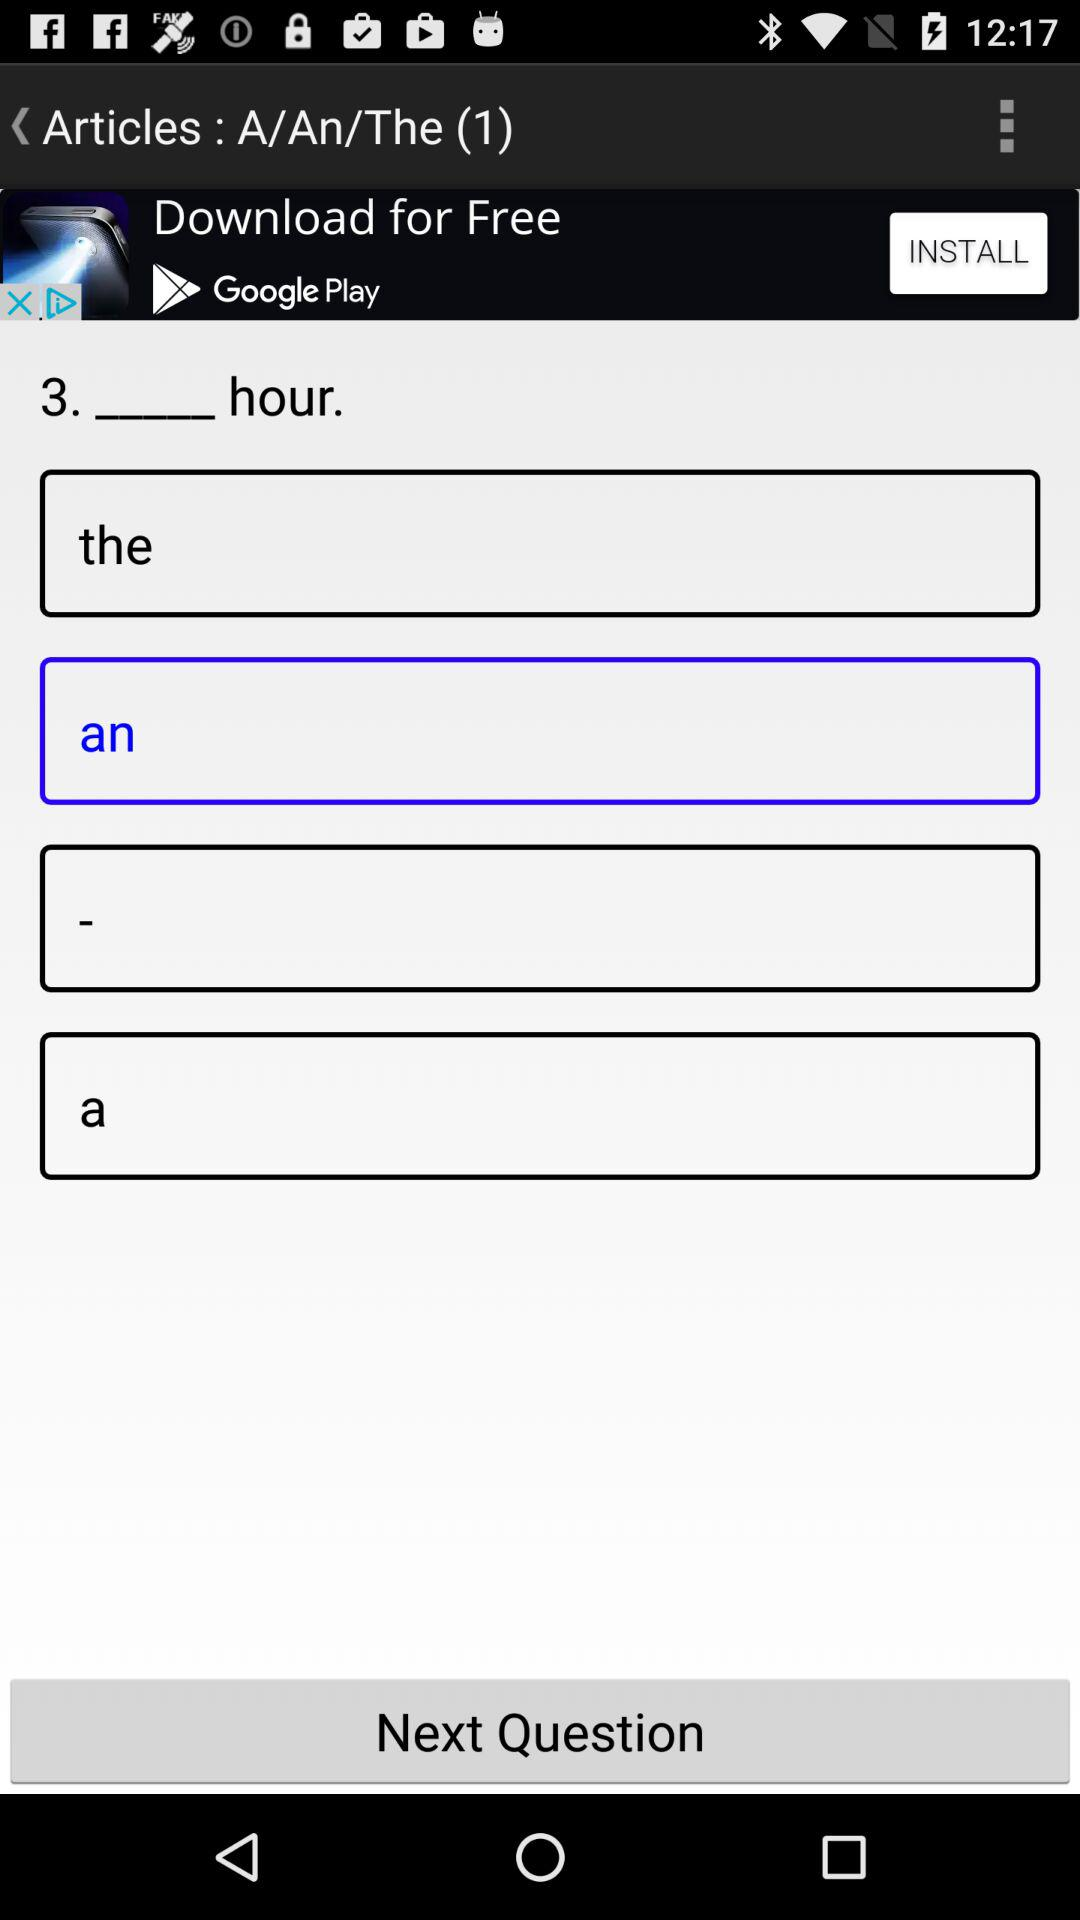What option is selected? The selected option is "an". 